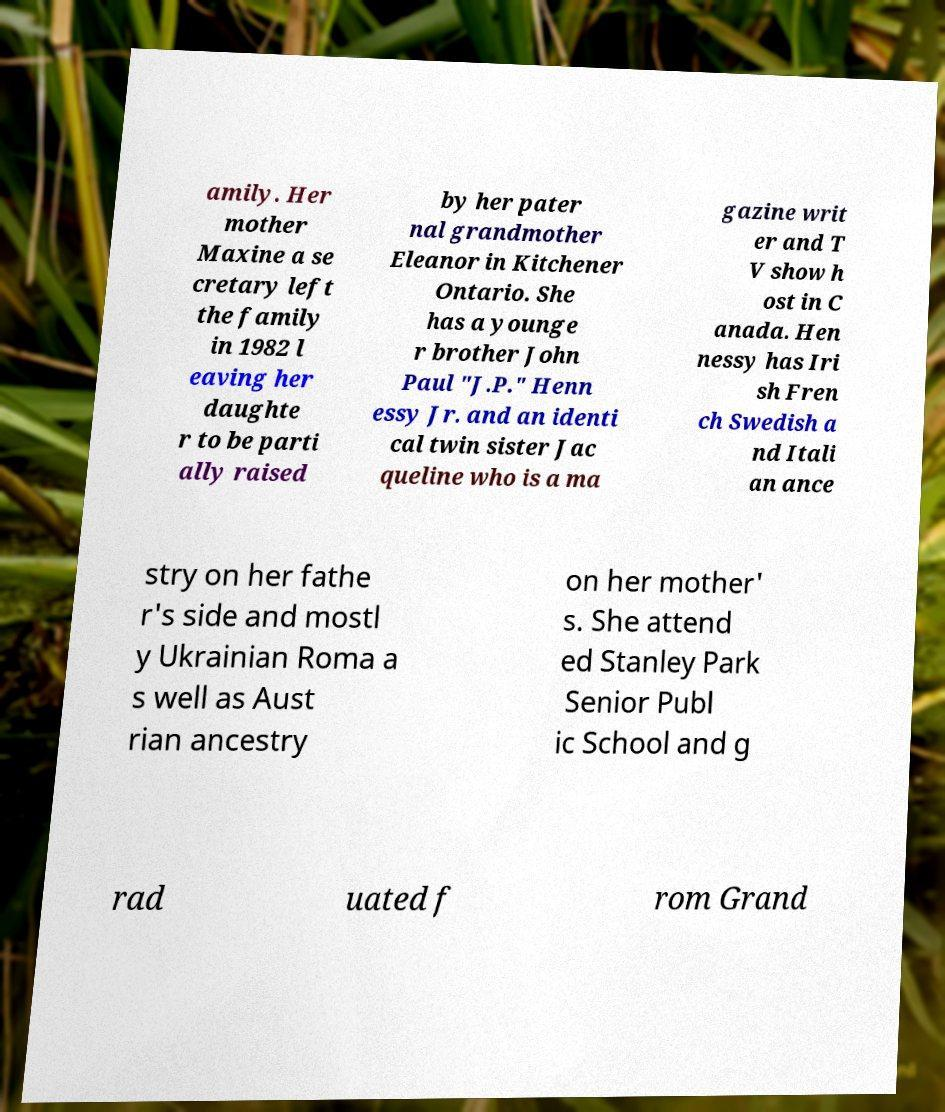For documentation purposes, I need the text within this image transcribed. Could you provide that? amily. Her mother Maxine a se cretary left the family in 1982 l eaving her daughte r to be parti ally raised by her pater nal grandmother Eleanor in Kitchener Ontario. She has a younge r brother John Paul "J.P." Henn essy Jr. and an identi cal twin sister Jac queline who is a ma gazine writ er and T V show h ost in C anada. Hen nessy has Iri sh Fren ch Swedish a nd Itali an ance stry on her fathe r's side and mostl y Ukrainian Roma a s well as Aust rian ancestry on her mother' s. She attend ed Stanley Park Senior Publ ic School and g rad uated f rom Grand 